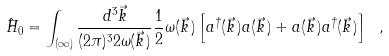<formula> <loc_0><loc_0><loc_500><loc_500>\hat { H } _ { 0 } = \int _ { ( \infty ) } \frac { d ^ { 3 } \vec { k } } { ( 2 \pi ) ^ { 3 } 2 \omega ( \vec { k } \, ) } \frac { 1 } { 2 } \omega ( \vec { k } \, ) \left [ a ^ { \dagger } ( \vec { k } \, ) a ( \vec { k } \, ) + a ( \vec { k } \, ) a ^ { \dagger } ( \vec { k } \, ) \right ] \ ,</formula> 